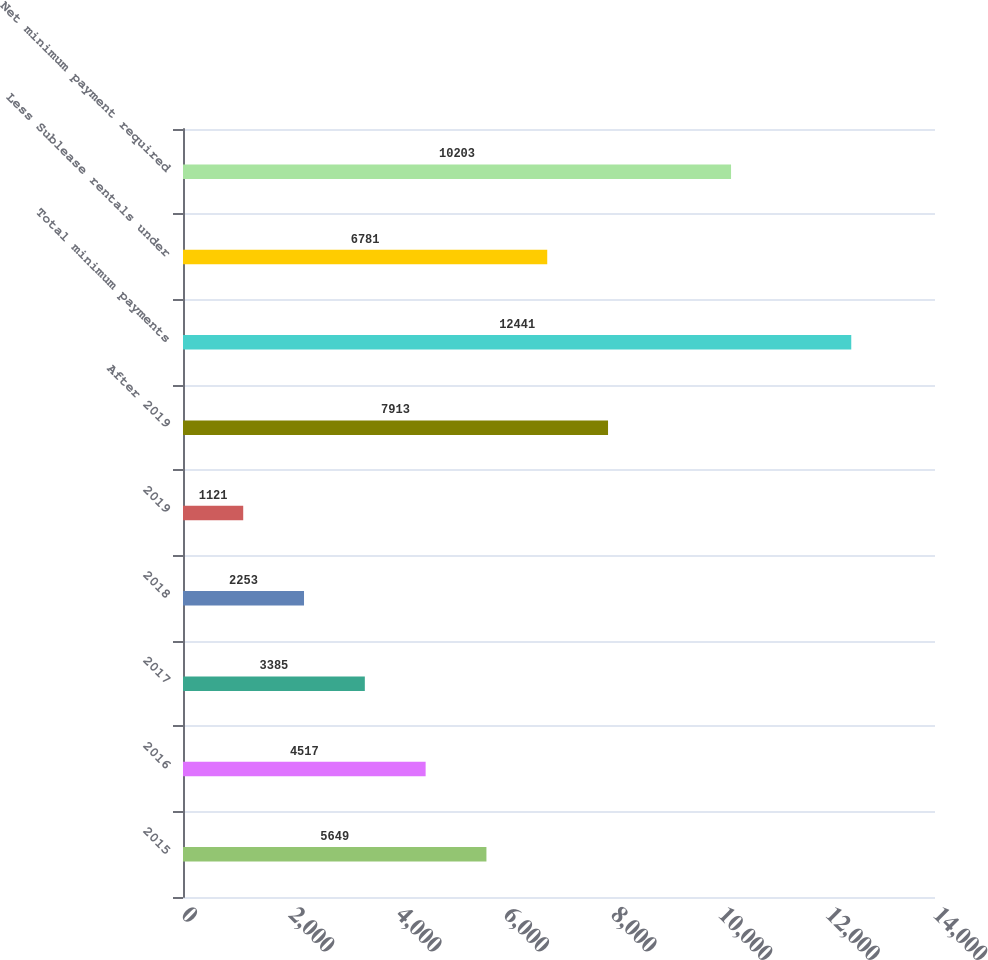Convert chart. <chart><loc_0><loc_0><loc_500><loc_500><bar_chart><fcel>2015<fcel>2016<fcel>2017<fcel>2018<fcel>2019<fcel>After 2019<fcel>Total minimum payments<fcel>Less Sublease rentals under<fcel>Net minimum payment required<nl><fcel>5649<fcel>4517<fcel>3385<fcel>2253<fcel>1121<fcel>7913<fcel>12441<fcel>6781<fcel>10203<nl></chart> 